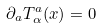<formula> <loc_0><loc_0><loc_500><loc_500>\partial _ { a } T ^ { a } _ { \alpha } ( x ) = 0</formula> 